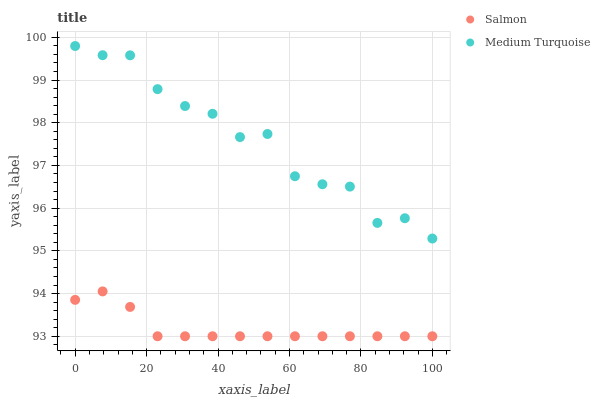Does Salmon have the minimum area under the curve?
Answer yes or no. Yes. Does Medium Turquoise have the maximum area under the curve?
Answer yes or no. Yes. Does Medium Turquoise have the minimum area under the curve?
Answer yes or no. No. Is Salmon the smoothest?
Answer yes or no. Yes. Is Medium Turquoise the roughest?
Answer yes or no. Yes. Is Medium Turquoise the smoothest?
Answer yes or no. No. Does Salmon have the lowest value?
Answer yes or no. Yes. Does Medium Turquoise have the lowest value?
Answer yes or no. No. Does Medium Turquoise have the highest value?
Answer yes or no. Yes. Is Salmon less than Medium Turquoise?
Answer yes or no. Yes. Is Medium Turquoise greater than Salmon?
Answer yes or no. Yes. Does Salmon intersect Medium Turquoise?
Answer yes or no. No. 